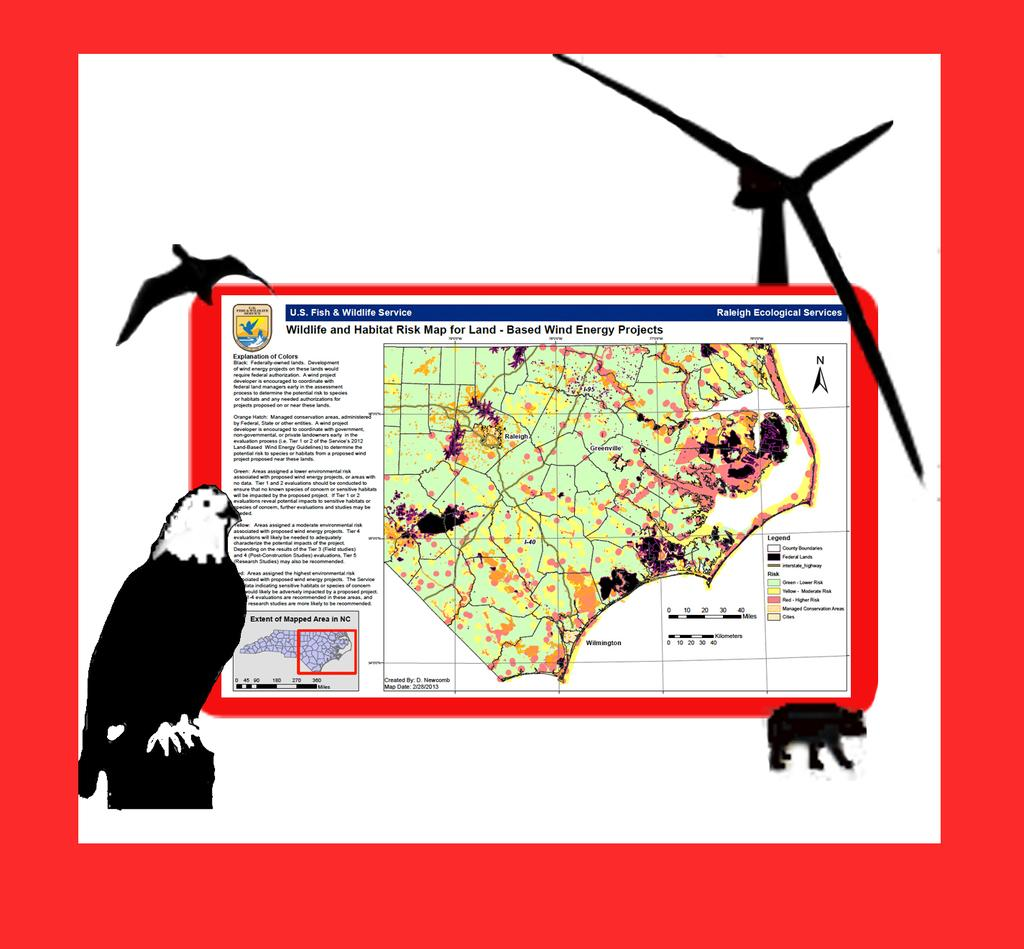What color is the border around the image? The image has a red color border. What is the main subject of the article in the image? The content of the article cannot be determined from the image. What type of animals are in the image? There are birds in the image. What object is present in the image that might provide air circulation? There is a wind fan in the image. How many trucks are visible in the image? There are no trucks present in the image. 